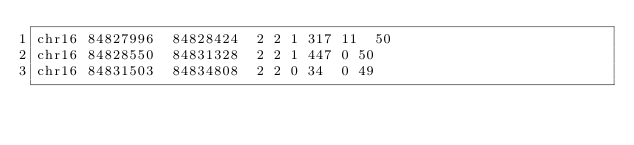<code> <loc_0><loc_0><loc_500><loc_500><_SQL_>chr16	84827996	84828424	2	2	1	317	11	50
chr16	84828550	84831328	2	2	1	447	0	50
chr16	84831503	84834808	2	2	0	34	0	49</code> 